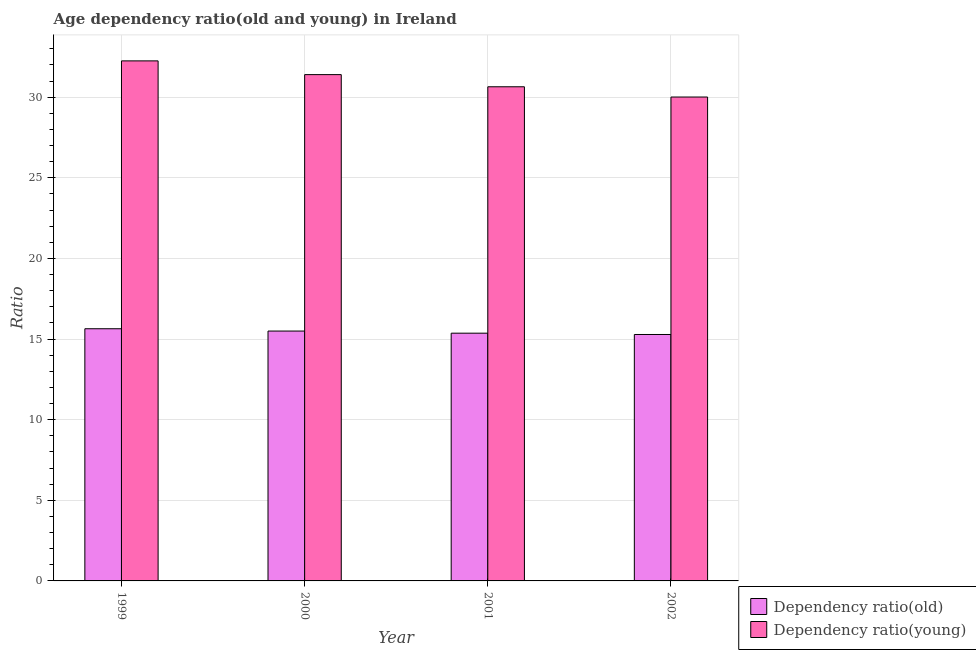How many different coloured bars are there?
Ensure brevity in your answer.  2. Are the number of bars on each tick of the X-axis equal?
Make the answer very short. Yes. How many bars are there on the 2nd tick from the left?
Provide a succinct answer. 2. In how many cases, is the number of bars for a given year not equal to the number of legend labels?
Keep it short and to the point. 0. What is the age dependency ratio(young) in 2001?
Your response must be concise. 30.65. Across all years, what is the maximum age dependency ratio(young)?
Ensure brevity in your answer.  32.26. Across all years, what is the minimum age dependency ratio(old)?
Keep it short and to the point. 15.28. What is the total age dependency ratio(young) in the graph?
Provide a short and direct response. 124.32. What is the difference between the age dependency ratio(young) in 2001 and that in 2002?
Provide a short and direct response. 0.64. What is the difference between the age dependency ratio(old) in 2000 and the age dependency ratio(young) in 2001?
Provide a succinct answer. 0.13. What is the average age dependency ratio(young) per year?
Your answer should be very brief. 31.08. In how many years, is the age dependency ratio(old) greater than 25?
Give a very brief answer. 0. What is the ratio of the age dependency ratio(young) in 1999 to that in 2002?
Offer a terse response. 1.07. Is the age dependency ratio(old) in 1999 less than that in 2000?
Your answer should be very brief. No. Is the difference between the age dependency ratio(old) in 1999 and 2001 greater than the difference between the age dependency ratio(young) in 1999 and 2001?
Your response must be concise. No. What is the difference between the highest and the second highest age dependency ratio(old)?
Make the answer very short. 0.14. What is the difference between the highest and the lowest age dependency ratio(young)?
Provide a succinct answer. 2.24. In how many years, is the age dependency ratio(old) greater than the average age dependency ratio(old) taken over all years?
Keep it short and to the point. 2. What does the 1st bar from the left in 2000 represents?
Your answer should be compact. Dependency ratio(old). What does the 1st bar from the right in 2001 represents?
Your answer should be compact. Dependency ratio(young). How many bars are there?
Give a very brief answer. 8. Are all the bars in the graph horizontal?
Offer a terse response. No. How many years are there in the graph?
Provide a short and direct response. 4. What is the difference between two consecutive major ticks on the Y-axis?
Your answer should be very brief. 5. Does the graph contain any zero values?
Give a very brief answer. No. Where does the legend appear in the graph?
Ensure brevity in your answer.  Bottom right. How are the legend labels stacked?
Provide a short and direct response. Vertical. What is the title of the graph?
Provide a succinct answer. Age dependency ratio(old and young) in Ireland. What is the label or title of the X-axis?
Your answer should be very brief. Year. What is the label or title of the Y-axis?
Your answer should be compact. Ratio. What is the Ratio of Dependency ratio(old) in 1999?
Your answer should be very brief. 15.64. What is the Ratio of Dependency ratio(young) in 1999?
Your answer should be very brief. 32.26. What is the Ratio of Dependency ratio(old) in 2000?
Provide a short and direct response. 15.5. What is the Ratio in Dependency ratio(young) in 2000?
Keep it short and to the point. 31.4. What is the Ratio in Dependency ratio(old) in 2001?
Ensure brevity in your answer.  15.37. What is the Ratio in Dependency ratio(young) in 2001?
Ensure brevity in your answer.  30.65. What is the Ratio in Dependency ratio(old) in 2002?
Offer a terse response. 15.28. What is the Ratio of Dependency ratio(young) in 2002?
Make the answer very short. 30.01. Across all years, what is the maximum Ratio in Dependency ratio(old)?
Your answer should be compact. 15.64. Across all years, what is the maximum Ratio in Dependency ratio(young)?
Your answer should be compact. 32.26. Across all years, what is the minimum Ratio of Dependency ratio(old)?
Ensure brevity in your answer.  15.28. Across all years, what is the minimum Ratio in Dependency ratio(young)?
Your answer should be compact. 30.01. What is the total Ratio in Dependency ratio(old) in the graph?
Ensure brevity in your answer.  61.79. What is the total Ratio of Dependency ratio(young) in the graph?
Give a very brief answer. 124.32. What is the difference between the Ratio in Dependency ratio(old) in 1999 and that in 2000?
Your response must be concise. 0.14. What is the difference between the Ratio of Dependency ratio(young) in 1999 and that in 2000?
Make the answer very short. 0.85. What is the difference between the Ratio in Dependency ratio(old) in 1999 and that in 2001?
Ensure brevity in your answer.  0.28. What is the difference between the Ratio in Dependency ratio(young) in 1999 and that in 2001?
Make the answer very short. 1.61. What is the difference between the Ratio in Dependency ratio(old) in 1999 and that in 2002?
Provide a short and direct response. 0.36. What is the difference between the Ratio of Dependency ratio(young) in 1999 and that in 2002?
Give a very brief answer. 2.24. What is the difference between the Ratio of Dependency ratio(old) in 2000 and that in 2001?
Provide a short and direct response. 0.13. What is the difference between the Ratio in Dependency ratio(young) in 2000 and that in 2001?
Make the answer very short. 0.75. What is the difference between the Ratio in Dependency ratio(old) in 2000 and that in 2002?
Make the answer very short. 0.21. What is the difference between the Ratio in Dependency ratio(young) in 2000 and that in 2002?
Ensure brevity in your answer.  1.39. What is the difference between the Ratio in Dependency ratio(old) in 2001 and that in 2002?
Offer a terse response. 0.08. What is the difference between the Ratio of Dependency ratio(young) in 2001 and that in 2002?
Keep it short and to the point. 0.64. What is the difference between the Ratio of Dependency ratio(old) in 1999 and the Ratio of Dependency ratio(young) in 2000?
Offer a terse response. -15.76. What is the difference between the Ratio in Dependency ratio(old) in 1999 and the Ratio in Dependency ratio(young) in 2001?
Give a very brief answer. -15.01. What is the difference between the Ratio in Dependency ratio(old) in 1999 and the Ratio in Dependency ratio(young) in 2002?
Your answer should be compact. -14.37. What is the difference between the Ratio in Dependency ratio(old) in 2000 and the Ratio in Dependency ratio(young) in 2001?
Your answer should be compact. -15.15. What is the difference between the Ratio of Dependency ratio(old) in 2000 and the Ratio of Dependency ratio(young) in 2002?
Make the answer very short. -14.52. What is the difference between the Ratio of Dependency ratio(old) in 2001 and the Ratio of Dependency ratio(young) in 2002?
Your response must be concise. -14.65. What is the average Ratio in Dependency ratio(old) per year?
Your answer should be very brief. 15.45. What is the average Ratio in Dependency ratio(young) per year?
Provide a short and direct response. 31.08. In the year 1999, what is the difference between the Ratio in Dependency ratio(old) and Ratio in Dependency ratio(young)?
Provide a short and direct response. -16.61. In the year 2000, what is the difference between the Ratio in Dependency ratio(old) and Ratio in Dependency ratio(young)?
Make the answer very short. -15.91. In the year 2001, what is the difference between the Ratio of Dependency ratio(old) and Ratio of Dependency ratio(young)?
Your answer should be very brief. -15.28. In the year 2002, what is the difference between the Ratio of Dependency ratio(old) and Ratio of Dependency ratio(young)?
Make the answer very short. -14.73. What is the ratio of the Ratio of Dependency ratio(old) in 1999 to that in 2000?
Make the answer very short. 1.01. What is the ratio of the Ratio of Dependency ratio(young) in 1999 to that in 2000?
Your answer should be compact. 1.03. What is the ratio of the Ratio of Dependency ratio(old) in 1999 to that in 2001?
Give a very brief answer. 1.02. What is the ratio of the Ratio in Dependency ratio(young) in 1999 to that in 2001?
Offer a terse response. 1.05. What is the ratio of the Ratio in Dependency ratio(old) in 1999 to that in 2002?
Your answer should be compact. 1.02. What is the ratio of the Ratio of Dependency ratio(young) in 1999 to that in 2002?
Keep it short and to the point. 1.07. What is the ratio of the Ratio of Dependency ratio(old) in 2000 to that in 2001?
Your response must be concise. 1.01. What is the ratio of the Ratio of Dependency ratio(young) in 2000 to that in 2001?
Your response must be concise. 1.02. What is the ratio of the Ratio in Dependency ratio(young) in 2000 to that in 2002?
Provide a short and direct response. 1.05. What is the ratio of the Ratio in Dependency ratio(old) in 2001 to that in 2002?
Your answer should be very brief. 1.01. What is the ratio of the Ratio in Dependency ratio(young) in 2001 to that in 2002?
Provide a short and direct response. 1.02. What is the difference between the highest and the second highest Ratio in Dependency ratio(old)?
Your answer should be compact. 0.14. What is the difference between the highest and the second highest Ratio in Dependency ratio(young)?
Your answer should be very brief. 0.85. What is the difference between the highest and the lowest Ratio in Dependency ratio(old)?
Your response must be concise. 0.36. What is the difference between the highest and the lowest Ratio of Dependency ratio(young)?
Provide a succinct answer. 2.24. 